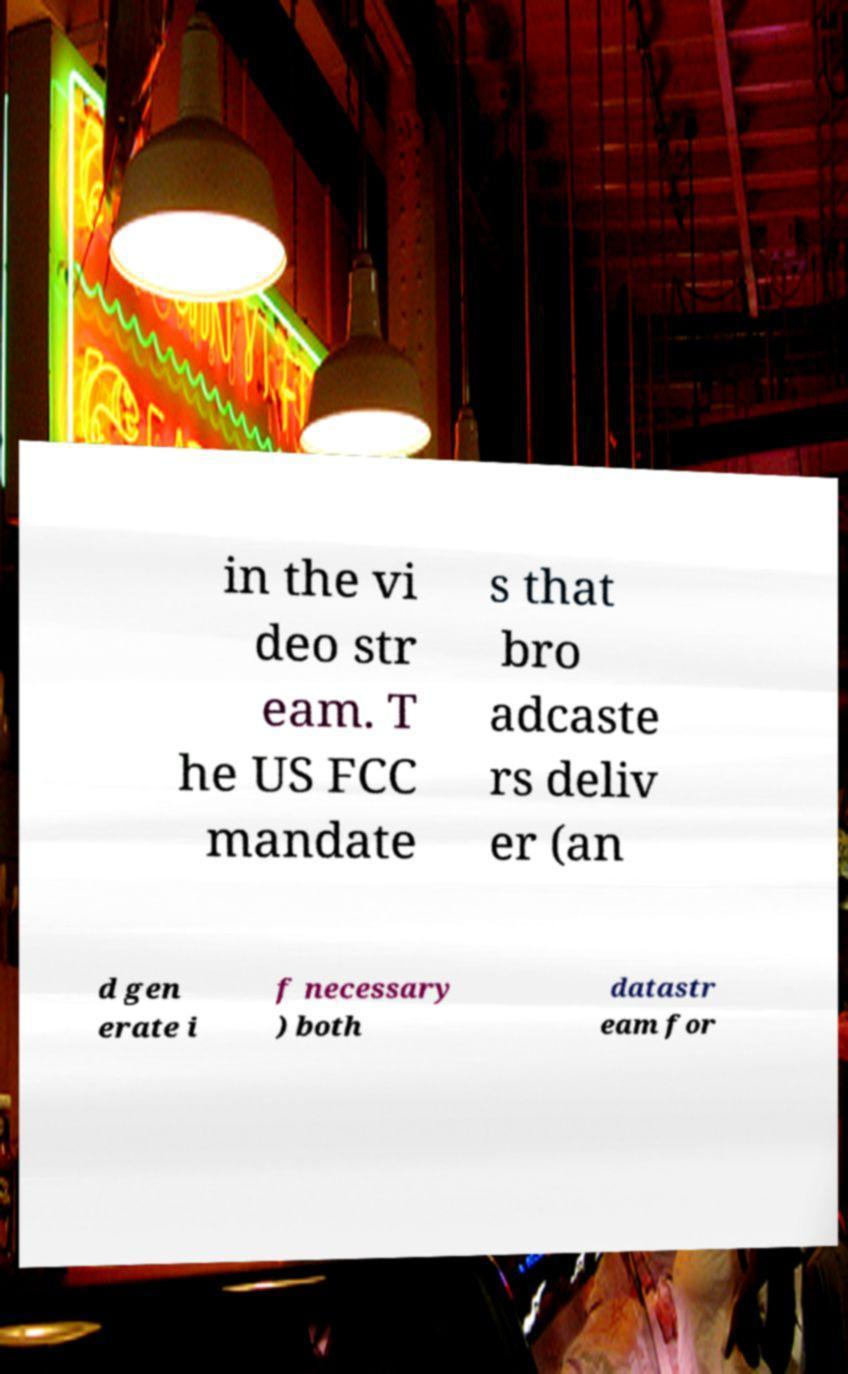Could you assist in decoding the text presented in this image and type it out clearly? in the vi deo str eam. T he US FCC mandate s that bro adcaste rs deliv er (an d gen erate i f necessary ) both datastr eam for 